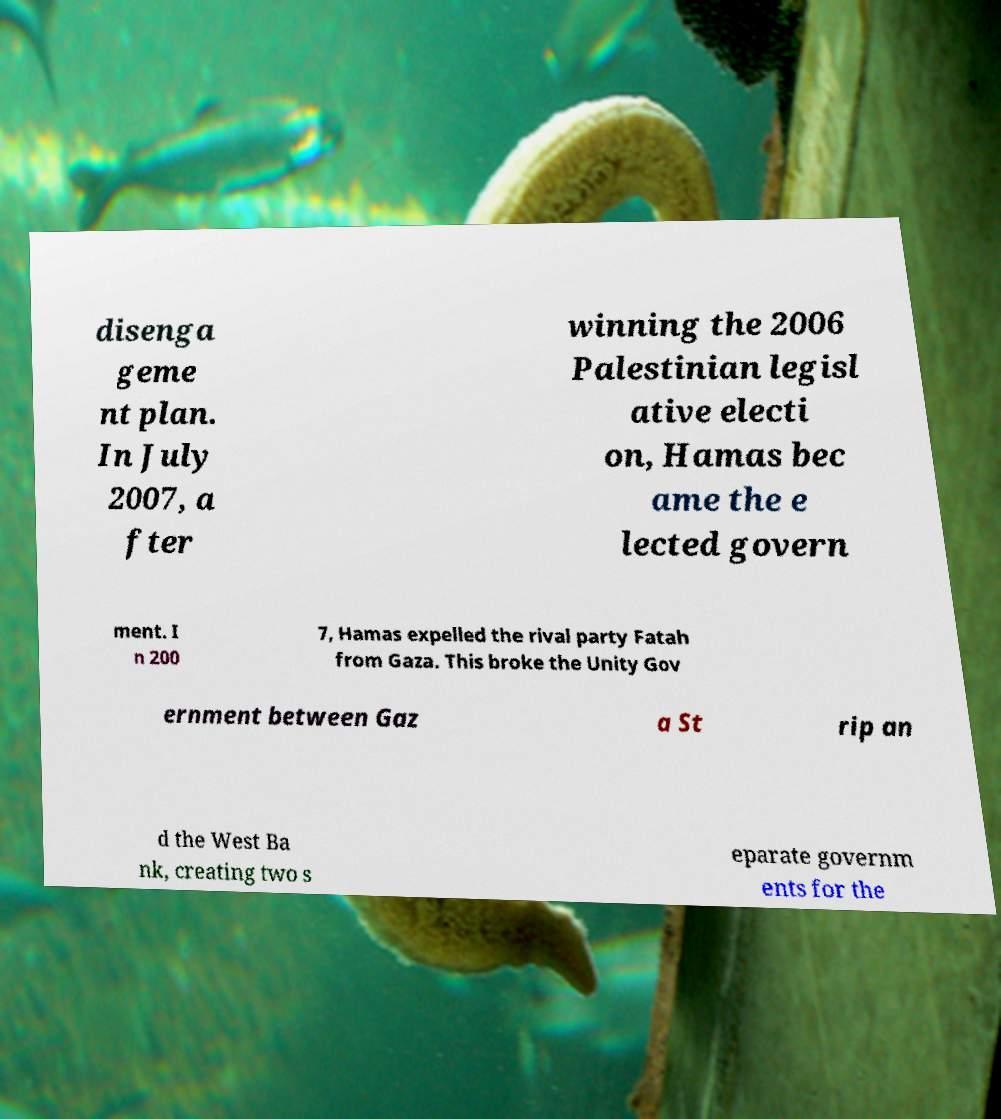Please read and relay the text visible in this image. What does it say? disenga geme nt plan. In July 2007, a fter winning the 2006 Palestinian legisl ative electi on, Hamas bec ame the e lected govern ment. I n 200 7, Hamas expelled the rival party Fatah from Gaza. This broke the Unity Gov ernment between Gaz a St rip an d the West Ba nk, creating two s eparate governm ents for the 